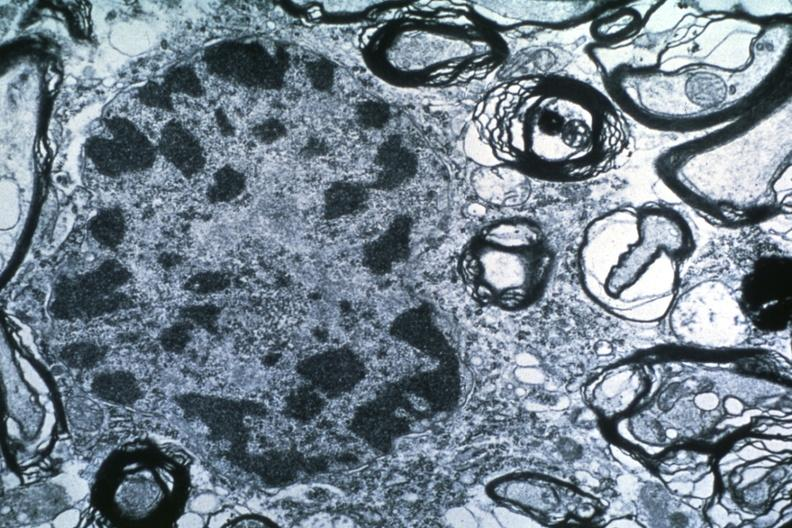what is present?
Answer the question using a single word or phrase. Lymphoma 